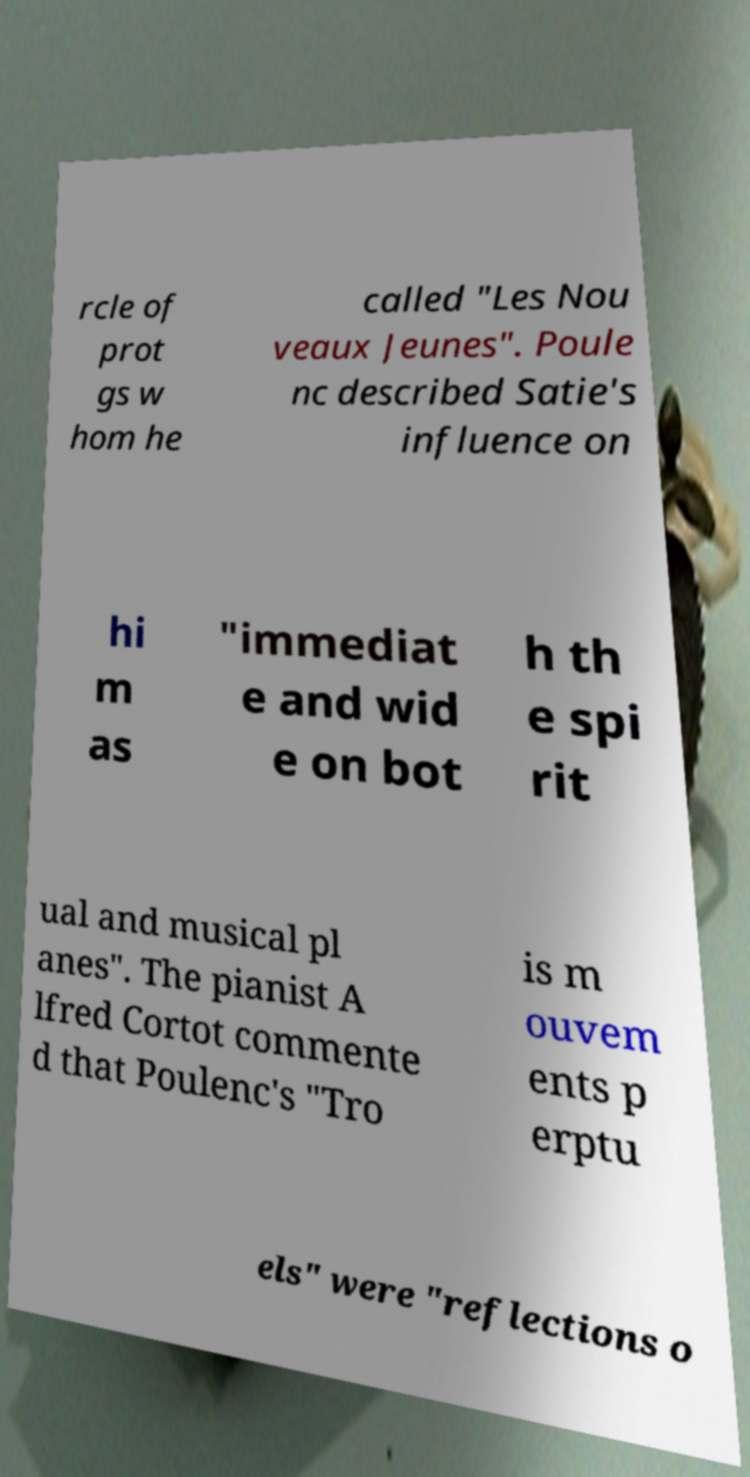Could you extract and type out the text from this image? rcle of prot gs w hom he called "Les Nou veaux Jeunes". Poule nc described Satie's influence on hi m as "immediat e and wid e on bot h th e spi rit ual and musical pl anes". The pianist A lfred Cortot commente d that Poulenc's "Tro is m ouvem ents p erptu els" were "reflections o 